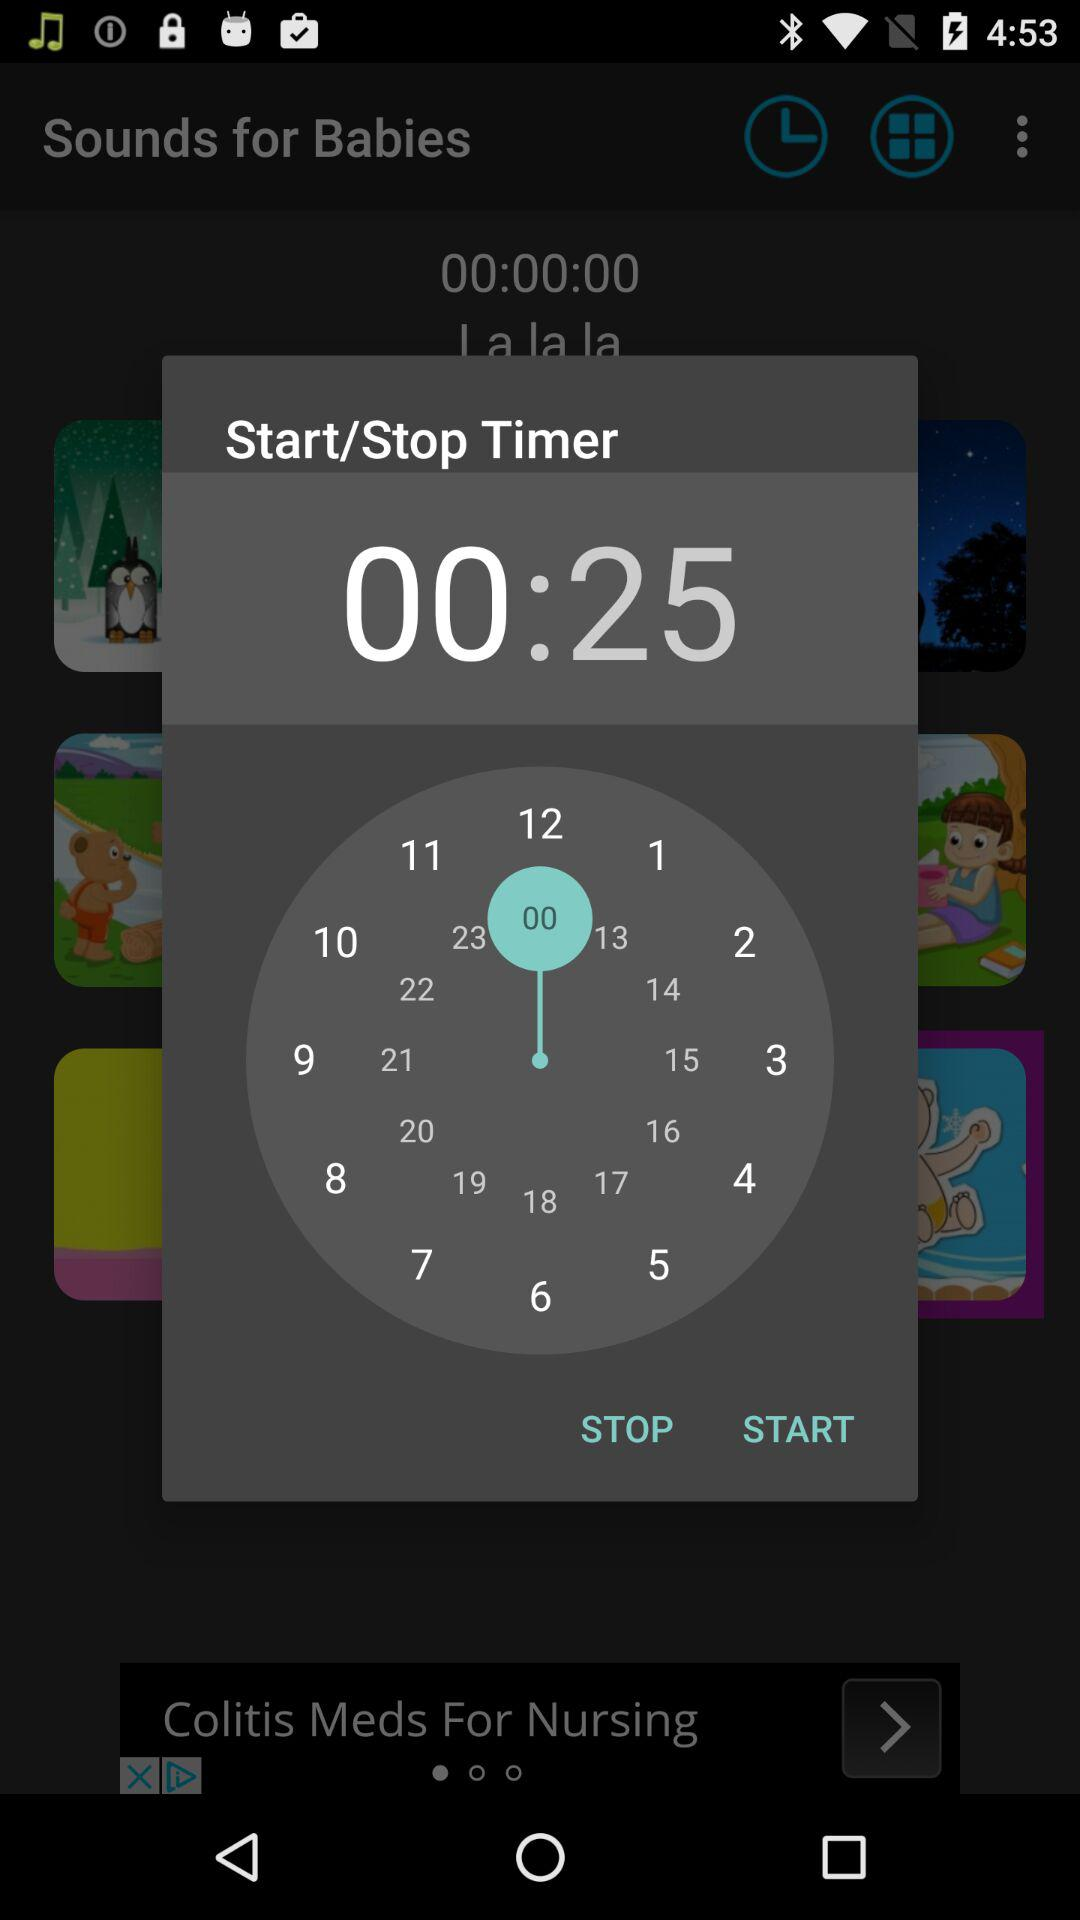How many minutes are left in the timer?
Answer the question using a single word or phrase. 25 